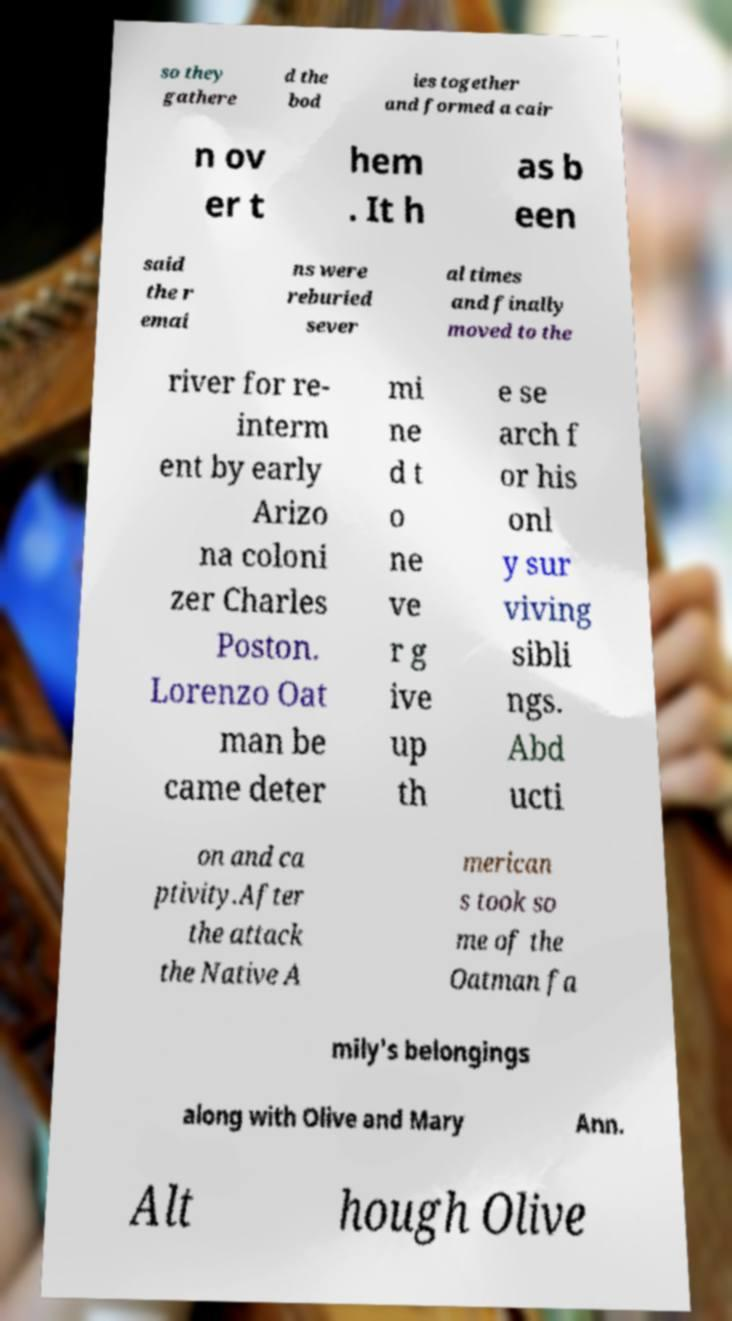For documentation purposes, I need the text within this image transcribed. Could you provide that? so they gathere d the bod ies together and formed a cair n ov er t hem . It h as b een said the r emai ns were reburied sever al times and finally moved to the river for re- interm ent by early Arizo na coloni zer Charles Poston. Lorenzo Oat man be came deter mi ne d t o ne ve r g ive up th e se arch f or his onl y sur viving sibli ngs. Abd ucti on and ca ptivity.After the attack the Native A merican s took so me of the Oatman fa mily's belongings along with Olive and Mary Ann. Alt hough Olive 